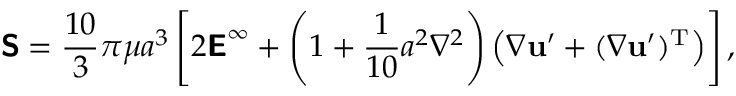<formula> <loc_0><loc_0><loc_500><loc_500>{ S } = { \frac { 1 0 } { 3 } } \pi \mu a ^ { 3 } \left [ 2 { E } ^ { \infty } + \left ( 1 + { \frac { 1 } { 1 0 } } a ^ { 2 } \nabla ^ { 2 } \right ) \left ( { \nabla } u ^ { \prime } + ( { \nabla } u ^ { \prime } ) ^ { T } \right ) \right ] ,</formula> 